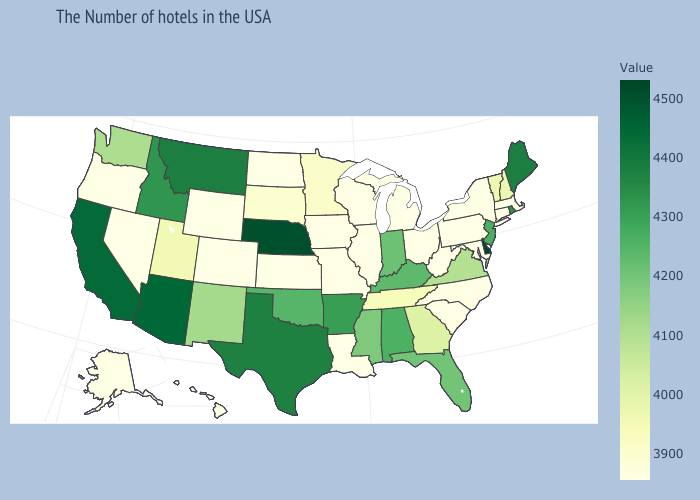Among the states that border New Mexico , does Arizona have the highest value?
Answer briefly. Yes. Which states have the lowest value in the USA?
Quick response, please. Massachusetts, Connecticut, New York, Pennsylvania, North Carolina, South Carolina, West Virginia, Ohio, Michigan, Wisconsin, Illinois, Louisiana, Missouri, Iowa, Kansas, North Dakota, Wyoming, Colorado, Nevada, Oregon, Alaska, Hawaii. Does the map have missing data?
Write a very short answer. No. Does the map have missing data?
Short answer required. No. Which states have the lowest value in the USA?
Quick response, please. Massachusetts, Connecticut, New York, Pennsylvania, North Carolina, South Carolina, West Virginia, Ohio, Michigan, Wisconsin, Illinois, Louisiana, Missouri, Iowa, Kansas, North Dakota, Wyoming, Colorado, Nevada, Oregon, Alaska, Hawaii. Does Delaware have the highest value in the USA?
Concise answer only. Yes. Which states have the lowest value in the South?
Quick response, please. North Carolina, South Carolina, West Virginia, Louisiana. 